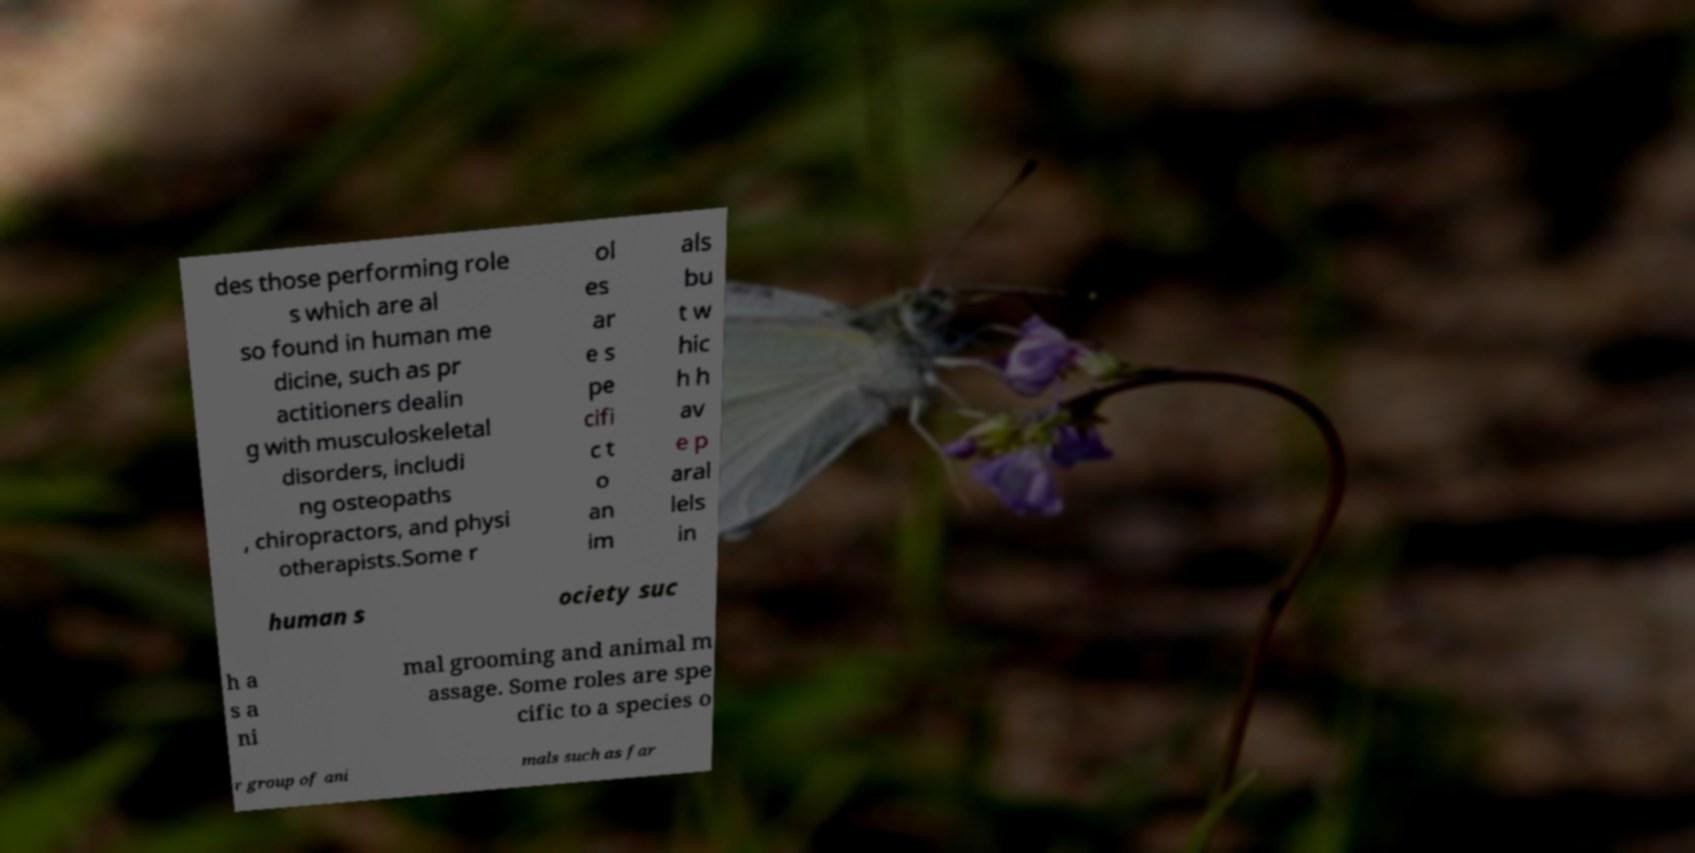For documentation purposes, I need the text within this image transcribed. Could you provide that? des those performing role s which are al so found in human me dicine, such as pr actitioners dealin g with musculoskeletal disorders, includi ng osteopaths , chiropractors, and physi otherapists.Some r ol es ar e s pe cifi c t o an im als bu t w hic h h av e p aral lels in human s ociety suc h a s a ni mal grooming and animal m assage. Some roles are spe cific to a species o r group of ani mals such as far 